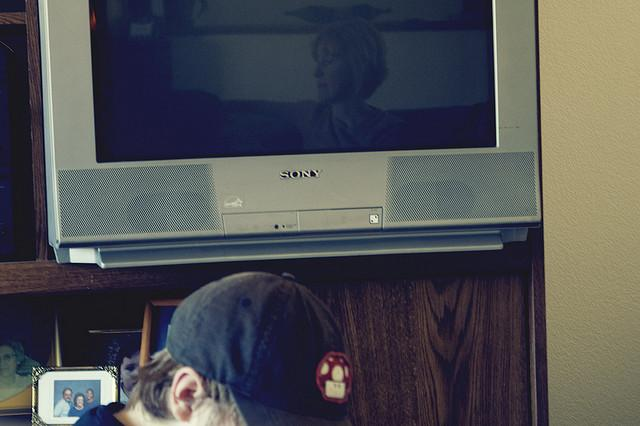When did the TV company start using this name?

Choices:
A) 1958
B) 1962
C) 1935
D) 1945 1958 